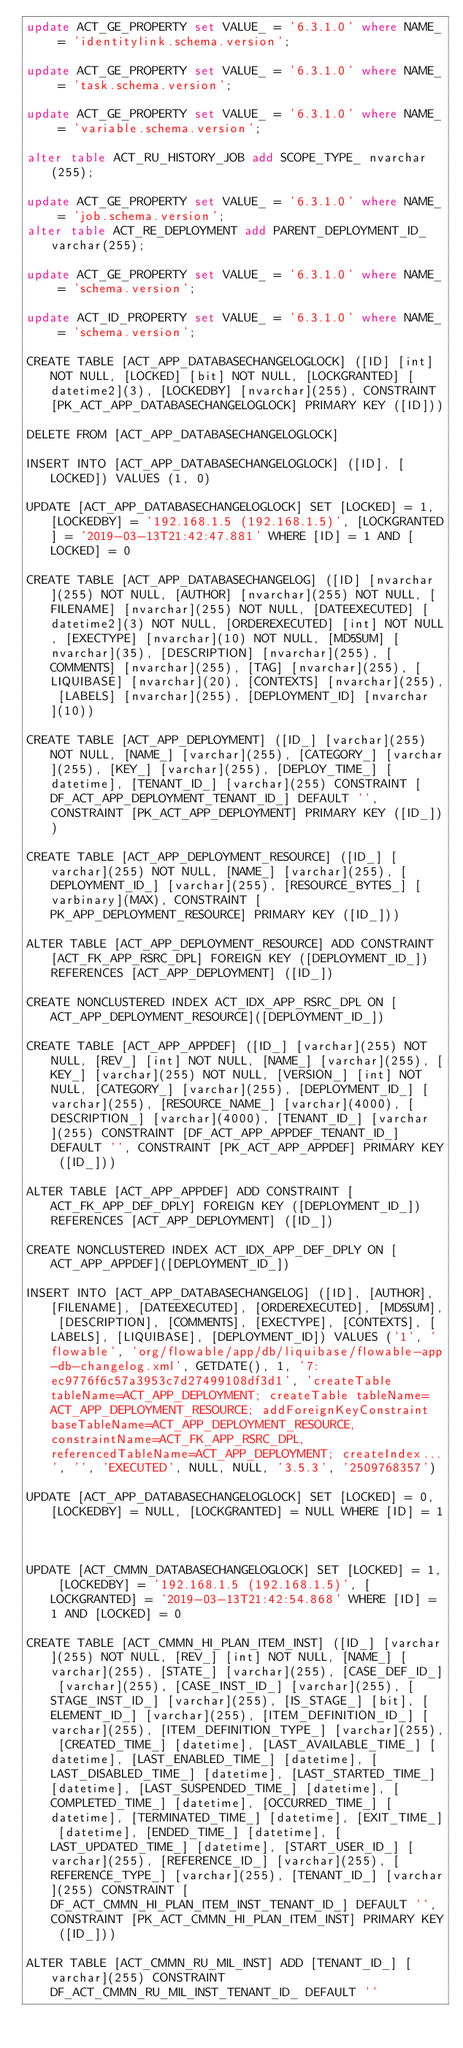<code> <loc_0><loc_0><loc_500><loc_500><_SQL_>update ACT_GE_PROPERTY set VALUE_ = '6.3.1.0' where NAME_ = 'identitylink.schema.version';

update ACT_GE_PROPERTY set VALUE_ = '6.3.1.0' where NAME_ = 'task.schema.version';

update ACT_GE_PROPERTY set VALUE_ = '6.3.1.0' where NAME_ = 'variable.schema.version';

alter table ACT_RU_HISTORY_JOB add SCOPE_TYPE_ nvarchar(255);

update ACT_GE_PROPERTY set VALUE_ = '6.3.1.0' where NAME_ = 'job.schema.version';
alter table ACT_RE_DEPLOYMENT add PARENT_DEPLOYMENT_ID_ varchar(255);

update ACT_GE_PROPERTY set VALUE_ = '6.3.1.0' where NAME_ = 'schema.version';

update ACT_ID_PROPERTY set VALUE_ = '6.3.1.0' where NAME_ = 'schema.version';

CREATE TABLE [ACT_APP_DATABASECHANGELOGLOCK] ([ID] [int] NOT NULL, [LOCKED] [bit] NOT NULL, [LOCKGRANTED] [datetime2](3), [LOCKEDBY] [nvarchar](255), CONSTRAINT [PK_ACT_APP_DATABASECHANGELOGLOCK] PRIMARY KEY ([ID]))

DELETE FROM [ACT_APP_DATABASECHANGELOGLOCK]

INSERT INTO [ACT_APP_DATABASECHANGELOGLOCK] ([ID], [LOCKED]) VALUES (1, 0)

UPDATE [ACT_APP_DATABASECHANGELOGLOCK] SET [LOCKED] = 1, [LOCKEDBY] = '192.168.1.5 (192.168.1.5)', [LOCKGRANTED] = '2019-03-13T21:42:47.881' WHERE [ID] = 1 AND [LOCKED] = 0

CREATE TABLE [ACT_APP_DATABASECHANGELOG] ([ID] [nvarchar](255) NOT NULL, [AUTHOR] [nvarchar](255) NOT NULL, [FILENAME] [nvarchar](255) NOT NULL, [DATEEXECUTED] [datetime2](3) NOT NULL, [ORDEREXECUTED] [int] NOT NULL, [EXECTYPE] [nvarchar](10) NOT NULL, [MD5SUM] [nvarchar](35), [DESCRIPTION] [nvarchar](255), [COMMENTS] [nvarchar](255), [TAG] [nvarchar](255), [LIQUIBASE] [nvarchar](20), [CONTEXTS] [nvarchar](255), [LABELS] [nvarchar](255), [DEPLOYMENT_ID] [nvarchar](10))

CREATE TABLE [ACT_APP_DEPLOYMENT] ([ID_] [varchar](255) NOT NULL, [NAME_] [varchar](255), [CATEGORY_] [varchar](255), [KEY_] [varchar](255), [DEPLOY_TIME_] [datetime], [TENANT_ID_] [varchar](255) CONSTRAINT [DF_ACT_APP_DEPLOYMENT_TENANT_ID_] DEFAULT '', CONSTRAINT [PK_ACT_APP_DEPLOYMENT] PRIMARY KEY ([ID_]))

CREATE TABLE [ACT_APP_DEPLOYMENT_RESOURCE] ([ID_] [varchar](255) NOT NULL, [NAME_] [varchar](255), [DEPLOYMENT_ID_] [varchar](255), [RESOURCE_BYTES_] [varbinary](MAX), CONSTRAINT [PK_APP_DEPLOYMENT_RESOURCE] PRIMARY KEY ([ID_]))

ALTER TABLE [ACT_APP_DEPLOYMENT_RESOURCE] ADD CONSTRAINT [ACT_FK_APP_RSRC_DPL] FOREIGN KEY ([DEPLOYMENT_ID_]) REFERENCES [ACT_APP_DEPLOYMENT] ([ID_])

CREATE NONCLUSTERED INDEX ACT_IDX_APP_RSRC_DPL ON [ACT_APP_DEPLOYMENT_RESOURCE]([DEPLOYMENT_ID_])

CREATE TABLE [ACT_APP_APPDEF] ([ID_] [varchar](255) NOT NULL, [REV_] [int] NOT NULL, [NAME_] [varchar](255), [KEY_] [varchar](255) NOT NULL, [VERSION_] [int] NOT NULL, [CATEGORY_] [varchar](255), [DEPLOYMENT_ID_] [varchar](255), [RESOURCE_NAME_] [varchar](4000), [DESCRIPTION_] [varchar](4000), [TENANT_ID_] [varchar](255) CONSTRAINT [DF_ACT_APP_APPDEF_TENANT_ID_] DEFAULT '', CONSTRAINT [PK_ACT_APP_APPDEF] PRIMARY KEY ([ID_]))

ALTER TABLE [ACT_APP_APPDEF] ADD CONSTRAINT [ACT_FK_APP_DEF_DPLY] FOREIGN KEY ([DEPLOYMENT_ID_]) REFERENCES [ACT_APP_DEPLOYMENT] ([ID_])

CREATE NONCLUSTERED INDEX ACT_IDX_APP_DEF_DPLY ON [ACT_APP_APPDEF]([DEPLOYMENT_ID_])

INSERT INTO [ACT_APP_DATABASECHANGELOG] ([ID], [AUTHOR], [FILENAME], [DATEEXECUTED], [ORDEREXECUTED], [MD5SUM], [DESCRIPTION], [COMMENTS], [EXECTYPE], [CONTEXTS], [LABELS], [LIQUIBASE], [DEPLOYMENT_ID]) VALUES ('1', 'flowable', 'org/flowable/app/db/liquibase/flowable-app-db-changelog.xml', GETDATE(), 1, '7:ec9776f6c57a3953c7d27499108df3d1', 'createTable tableName=ACT_APP_DEPLOYMENT; createTable tableName=ACT_APP_DEPLOYMENT_RESOURCE; addForeignKeyConstraint baseTableName=ACT_APP_DEPLOYMENT_RESOURCE, constraintName=ACT_FK_APP_RSRC_DPL, referencedTableName=ACT_APP_DEPLOYMENT; createIndex...', '', 'EXECUTED', NULL, NULL, '3.5.3', '2509768357')

UPDATE [ACT_APP_DATABASECHANGELOGLOCK] SET [LOCKED] = 0, [LOCKEDBY] = NULL, [LOCKGRANTED] = NULL WHERE [ID] = 1



UPDATE [ACT_CMMN_DATABASECHANGELOGLOCK] SET [LOCKED] = 1, [LOCKEDBY] = '192.168.1.5 (192.168.1.5)', [LOCKGRANTED] = '2019-03-13T21:42:54.868' WHERE [ID] = 1 AND [LOCKED] = 0

CREATE TABLE [ACT_CMMN_HI_PLAN_ITEM_INST] ([ID_] [varchar](255) NOT NULL, [REV_] [int] NOT NULL, [NAME_] [varchar](255), [STATE_] [varchar](255), [CASE_DEF_ID_] [varchar](255), [CASE_INST_ID_] [varchar](255), [STAGE_INST_ID_] [varchar](255), [IS_STAGE_] [bit], [ELEMENT_ID_] [varchar](255), [ITEM_DEFINITION_ID_] [varchar](255), [ITEM_DEFINITION_TYPE_] [varchar](255), [CREATED_TIME_] [datetime], [LAST_AVAILABLE_TIME_] [datetime], [LAST_ENABLED_TIME_] [datetime], [LAST_DISABLED_TIME_] [datetime], [LAST_STARTED_TIME_] [datetime], [LAST_SUSPENDED_TIME_] [datetime], [COMPLETED_TIME_] [datetime], [OCCURRED_TIME_] [datetime], [TERMINATED_TIME_] [datetime], [EXIT_TIME_] [datetime], [ENDED_TIME_] [datetime], [LAST_UPDATED_TIME_] [datetime], [START_USER_ID_] [varchar](255), [REFERENCE_ID_] [varchar](255), [REFERENCE_TYPE_] [varchar](255), [TENANT_ID_] [varchar](255) CONSTRAINT [DF_ACT_CMMN_HI_PLAN_ITEM_INST_TENANT_ID_] DEFAULT '', CONSTRAINT [PK_ACT_CMMN_HI_PLAN_ITEM_INST] PRIMARY KEY ([ID_]))

ALTER TABLE [ACT_CMMN_RU_MIL_INST] ADD [TENANT_ID_] [varchar](255) CONSTRAINT DF_ACT_CMMN_RU_MIL_INST_TENANT_ID_ DEFAULT ''
</code> 